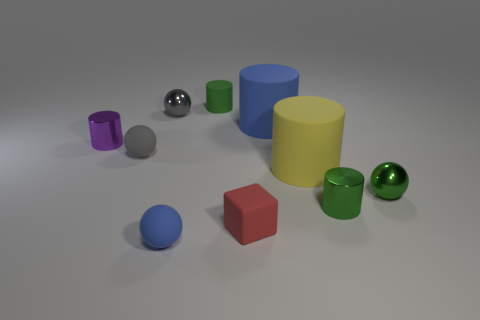Subtract all purple cylinders. How many cylinders are left? 4 Subtract all green metallic cylinders. How many cylinders are left? 4 Subtract all purple spheres. Subtract all yellow cylinders. How many spheres are left? 4 Subtract all blocks. How many objects are left? 9 Add 1 brown metallic spheres. How many brown metallic spheres exist? 1 Subtract 0 brown spheres. How many objects are left? 10 Subtract all small gray matte objects. Subtract all tiny blue matte objects. How many objects are left? 8 Add 2 blue rubber cylinders. How many blue rubber cylinders are left? 3 